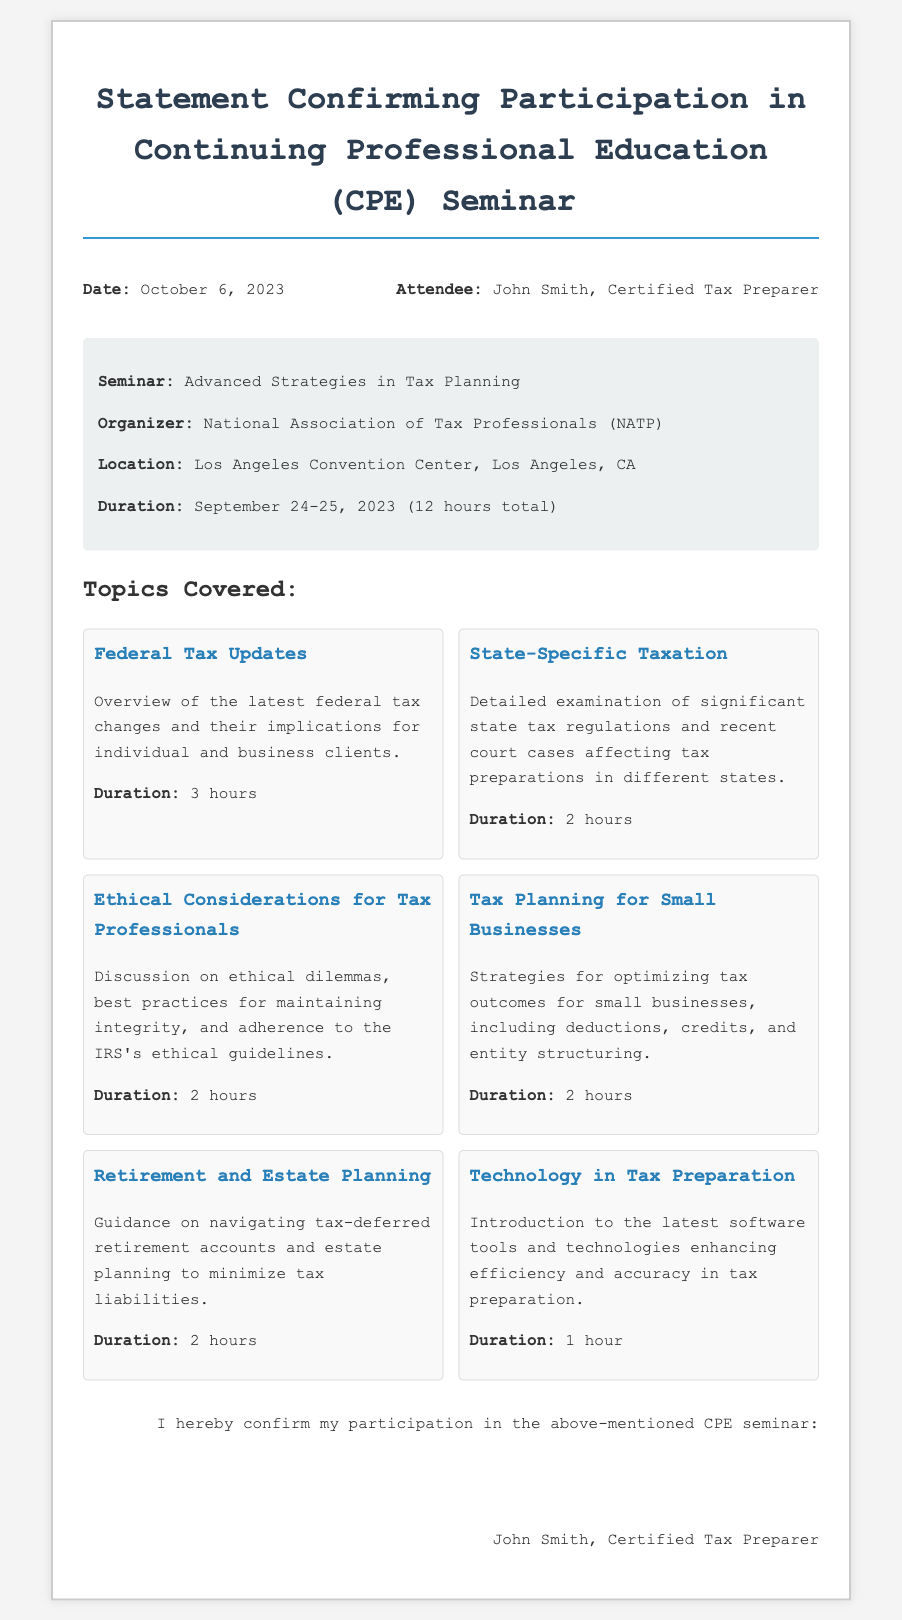What is the date of the seminar? The date of the seminar can be found in the header information section of the document.
Answer: October 6, 2023 Who organized the seminar? The organizer of the seminar is mentioned in the seminar details section of the document.
Answer: National Association of Tax Professionals What is the location of the seminar? The location is specified in the seminar details section.
Answer: Los Angeles Convention Center, Los Angeles, CA How many total hours did the seminar last? The duration of the seminar is provided in the seminar details section.
Answer: 12 hours total What topic covers the latest federal tax changes? This topic is listed under the topics covered section.
Answer: Federal Tax Updates How many hours were dedicated to retirement and estate planning? The duration is specified in the topic description for retirement and estate planning.
Answer: 2 hours What does the document confirm? The primary purpose of the document is stated in the title and signature sections.
Answer: Participation in the above-mentioned CPE seminar Who was the attendee of the seminar? The attendee's name is provided in the header information.
Answer: John Smith, Certified Tax Preparer 